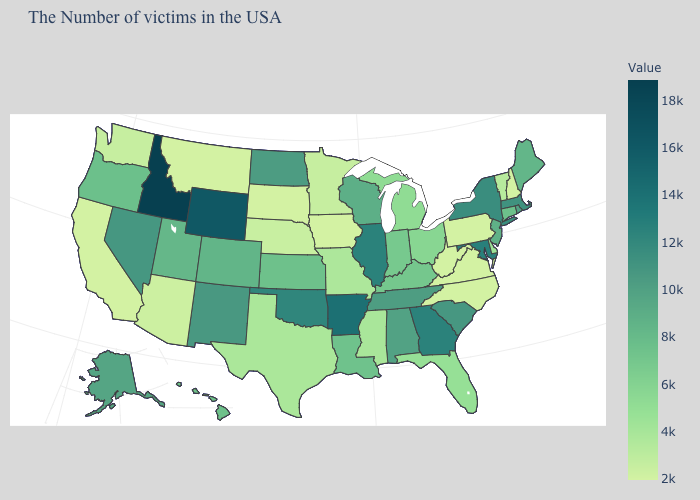Which states have the lowest value in the USA?
Give a very brief answer. New Hampshire, Pennsylvania, Virginia, North Carolina, West Virginia, Iowa, South Dakota, Montana, California. Which states hav the highest value in the Northeast?
Write a very short answer. New York. Which states hav the highest value in the South?
Keep it brief. Arkansas. Does New Jersey have the highest value in the Northeast?
Answer briefly. No. 